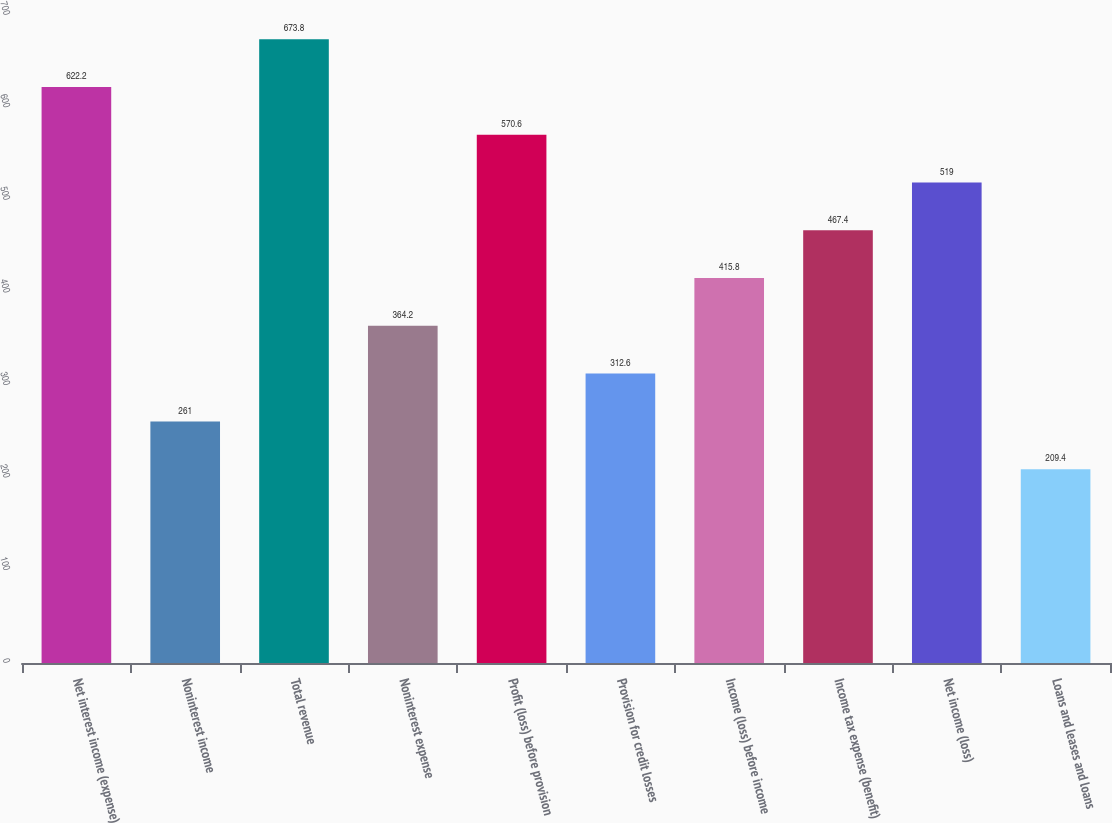Convert chart to OTSL. <chart><loc_0><loc_0><loc_500><loc_500><bar_chart><fcel>Net interest income (expense)<fcel>Noninterest income<fcel>Total revenue<fcel>Noninterest expense<fcel>Profit (loss) before provision<fcel>Provision for credit losses<fcel>Income (loss) before income<fcel>Income tax expense (benefit)<fcel>Net income (loss)<fcel>Loans and leases and loans<nl><fcel>622.2<fcel>261<fcel>673.8<fcel>364.2<fcel>570.6<fcel>312.6<fcel>415.8<fcel>467.4<fcel>519<fcel>209.4<nl></chart> 